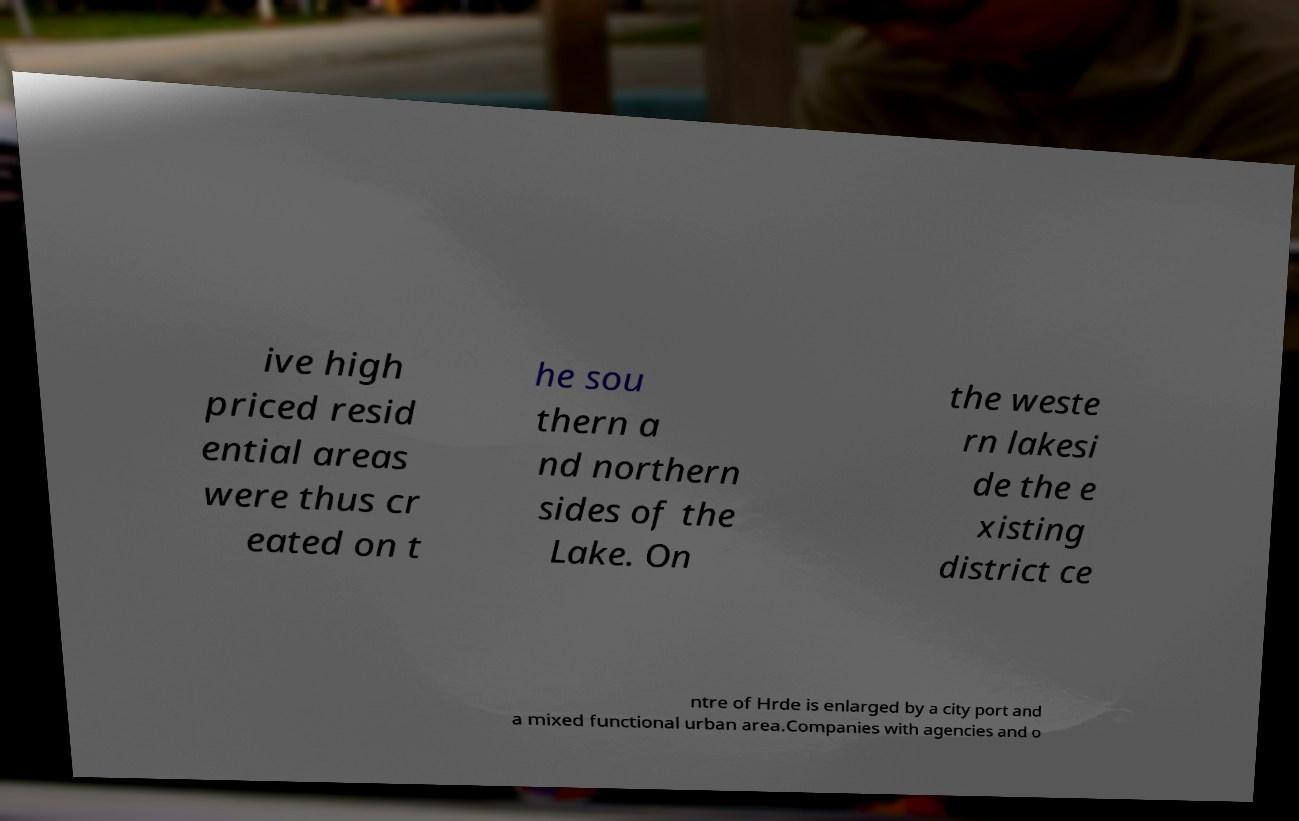For documentation purposes, I need the text within this image transcribed. Could you provide that? ive high priced resid ential areas were thus cr eated on t he sou thern a nd northern sides of the Lake. On the weste rn lakesi de the e xisting district ce ntre of Hrde is enlarged by a city port and a mixed functional urban area.Companies with agencies and o 